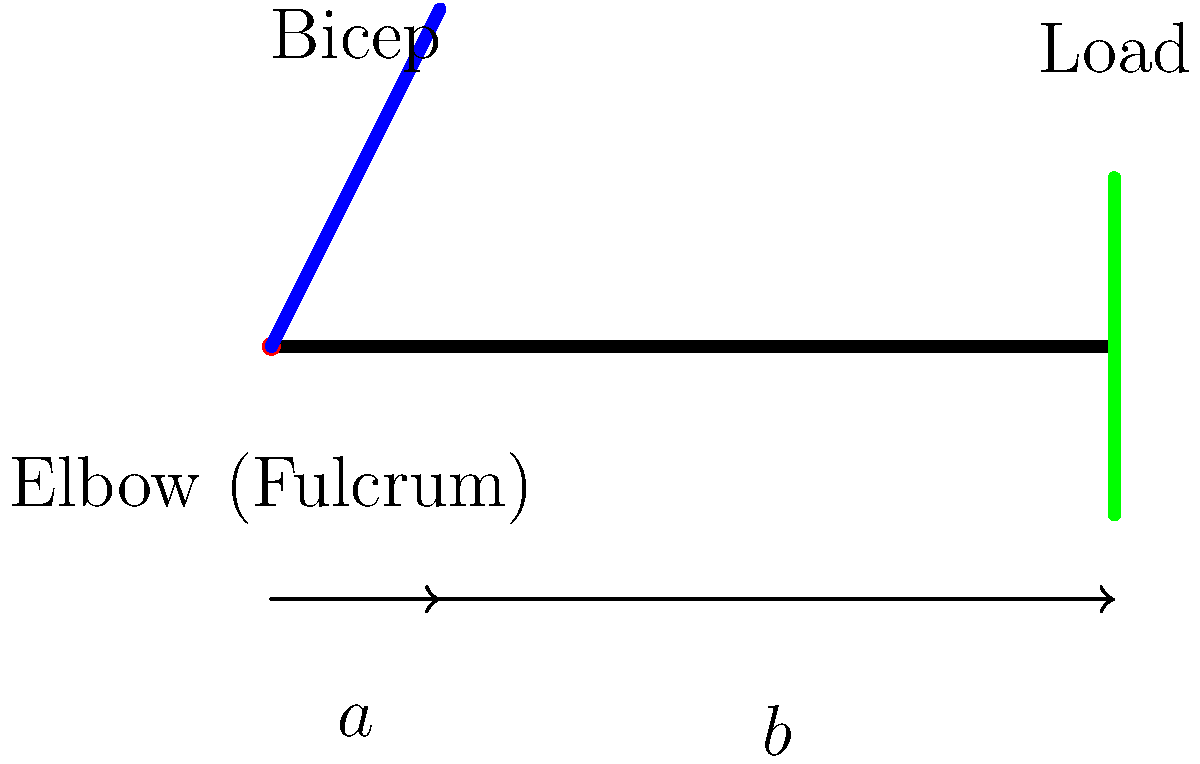In the context of the human arm as a third-class lever system, how does the mechanical advantage relate to the effort required by the bicep muscle? Consider the philosophical implications of this biomechanical relationship on the concept of human physical limitations. Let's approach this step-by-step:

1) In a lever system, the mechanical advantage (MA) is defined as the ratio of the output force to the input force. Mathematically, it's expressed as:

   $$ MA = \frac{F_{out}}{F_{in}} $$

2) For a third-class lever, like the human arm, the mechanical advantage is always less than 1. This is because the effort (bicep muscle) is applied between the fulcrum (elbow joint) and the load.

3) The mechanical advantage can also be calculated using the distances:

   $$ MA = \frac{a}{b} $$

   Where $a$ is the distance from the fulcrum to the effort, and $b$ is the distance from the fulcrum to the load.

4) In the human arm, $a$ is always shorter than $b$, resulting in a mechanical advantage less than 1.

5) This means that the force exerted by the bicep (F_in) must be greater than the force of the load (F_out):

   $$ F_{in} > F_{out} $$

6) While this might seem inefficient, it allows for a greater range of motion and speed of movement at the expense of force.

7) Philosophically, this biomechanical constraint reflects the inherent trade-offs in human physical design. It demonstrates that our bodies are not optimized for brute strength, but for versatility and fine motor control.

8) This limitation also highlights the concept of human finitude - our physical capabilities are bounded by the mechanical properties of our anatomy.

9) However, humans have used their cognitive abilities to overcome these physical limitations through tool use and technology, raising questions about the relationship between our physical and mental capacities.

10) The study of these biomechanical systems can lead to deeper philosophical inquiries about the nature of human embodiment, the mind-body problem, and the role of physical constraints in shaping human experience and cognition.
Answer: Mechanical advantage < 1; greater effort required; reflects trade-off between strength and versatility in human design. 